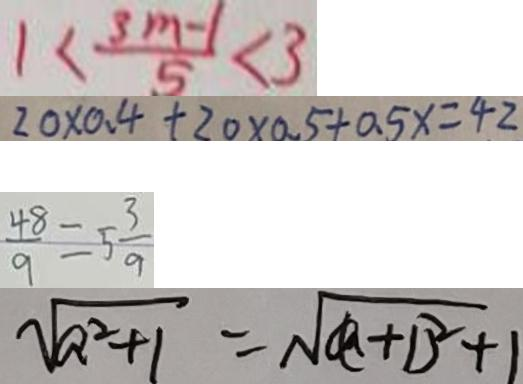Convert formula to latex. <formula><loc_0><loc_0><loc_500><loc_500>1 < \frac { 3 m - 1 } { 5 } < 3 
 2 0 \times 0 . 4 + 2 0 \times 0 . 5 + 0 . 5 x = 4 2 
 \frac { 4 8 } { 9 } = 5 \frac { 3 } { 9 } 
 \sqrt { a ^ { 2 } + 1 } = \sqrt { a + 1 ^ { 2 } + 1 }</formula> 